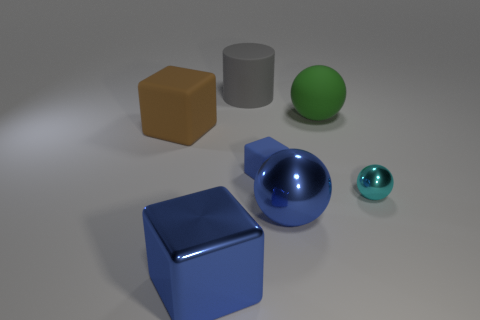What material is the small block that is the same color as the large metal ball?
Give a very brief answer. Rubber. There is a object that is both behind the brown block and left of the large green rubber ball; how big is it?
Make the answer very short. Large. The cyan thing that is the same shape as the big green rubber object is what size?
Make the answer very short. Small. Is the material of the large thing that is to the left of the big blue cube the same as the big blue object behind the shiny block?
Your response must be concise. No. What material is the large blue object left of the blue metallic object behind the large cube in front of the small sphere made of?
Your answer should be compact. Metal. There is a tiny thing that is behind the small metal ball; does it have the same shape as the large rubber object that is in front of the big green matte ball?
Your answer should be compact. Yes. The large metallic object on the right side of the blue object on the left side of the blue rubber cube is what color?
Provide a short and direct response. Blue. How many cylinders are large green objects or blue shiny objects?
Offer a very short reply. 0. How many cyan things are right of the large metal object on the right side of the rubber object that is in front of the brown matte block?
Keep it short and to the point. 1. The shiny thing that is the same color as the large metallic cube is what size?
Ensure brevity in your answer.  Large. 